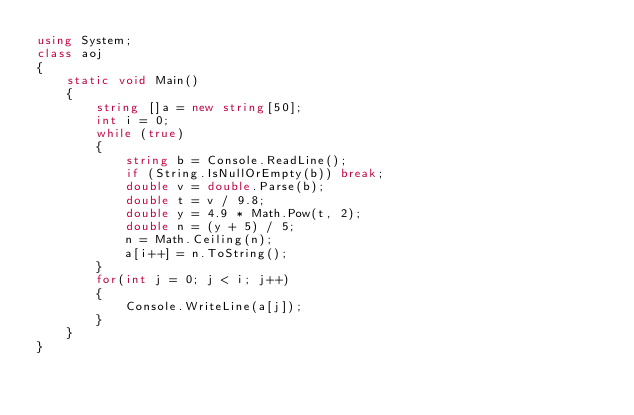Convert code to text. <code><loc_0><loc_0><loc_500><loc_500><_C#_>using System;
class aoj
{
    static void Main()
    {
        string []a = new string[50];
        int i = 0;
        while (true)
        {
            string b = Console.ReadLine();
            if (String.IsNullOrEmpty(b)) break;
            double v = double.Parse(b);
            double t = v / 9.8;
            double y = 4.9 * Math.Pow(t, 2);
            double n = (y + 5) / 5;
            n = Math.Ceiling(n);
            a[i++] = n.ToString();
        }
        for(int j = 0; j < i; j++)
        {
            Console.WriteLine(a[j]);
        }
    }
}</code> 